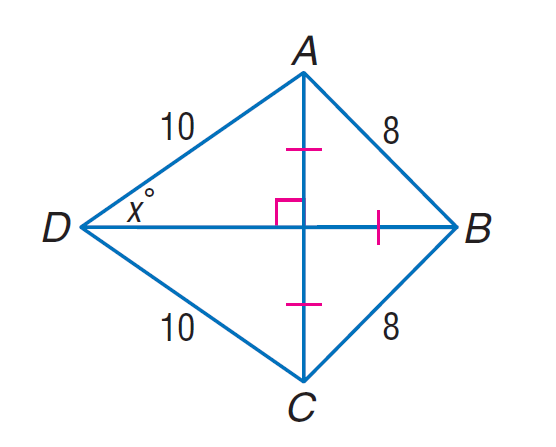Question: Find \sin x.
Choices:
A. \frac { \sqrt { 2 } } { 10 }
B. \frac { \sqrt { 2 } } { 5 }
C. \frac { \sqrt { 5 } } { 5 }
D. \frac { 2 \sqrt { 2 } } { 5 }
Answer with the letter. Answer: D 